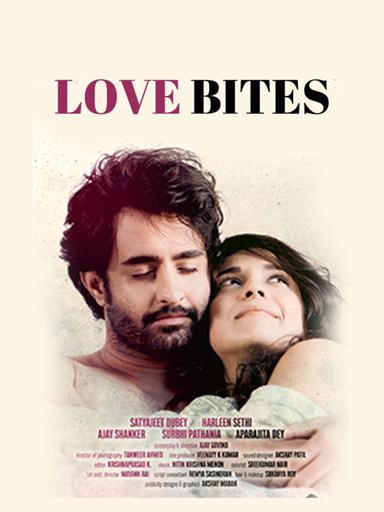Can you describe any symbolic elements visible in the 'Love Bites' movie poster? The 'Love Bites' poster includes subtle symbolic elements such as the gentle embrace between the two main characters, symbolizing connection and comfort. The background's soft focus might suggest a memory or dream-like state, emphasizing the film's exploration of emotional depths and past experiences influencing the present. 